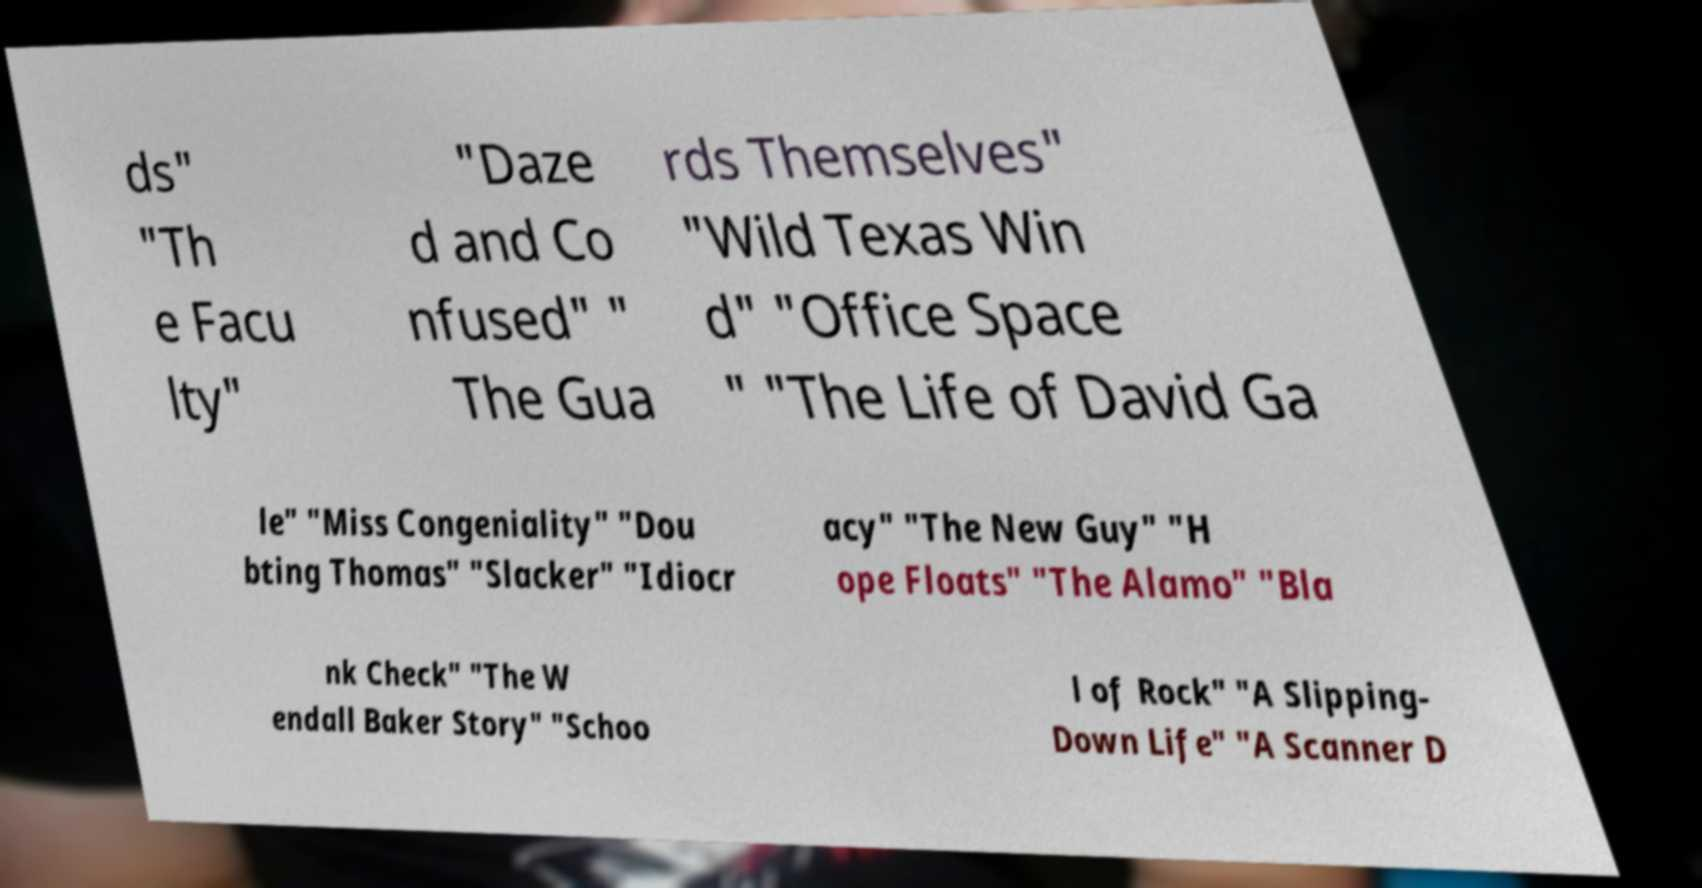Please read and relay the text visible in this image. What does it say? ds" "Th e Facu lty" "Daze d and Co nfused" " The Gua rds Themselves" "Wild Texas Win d" "Office Space " "The Life of David Ga le" "Miss Congeniality" "Dou bting Thomas" "Slacker" "Idiocr acy" "The New Guy" "H ope Floats" "The Alamo" "Bla nk Check" "The W endall Baker Story" "Schoo l of Rock" "A Slipping- Down Life" "A Scanner D 